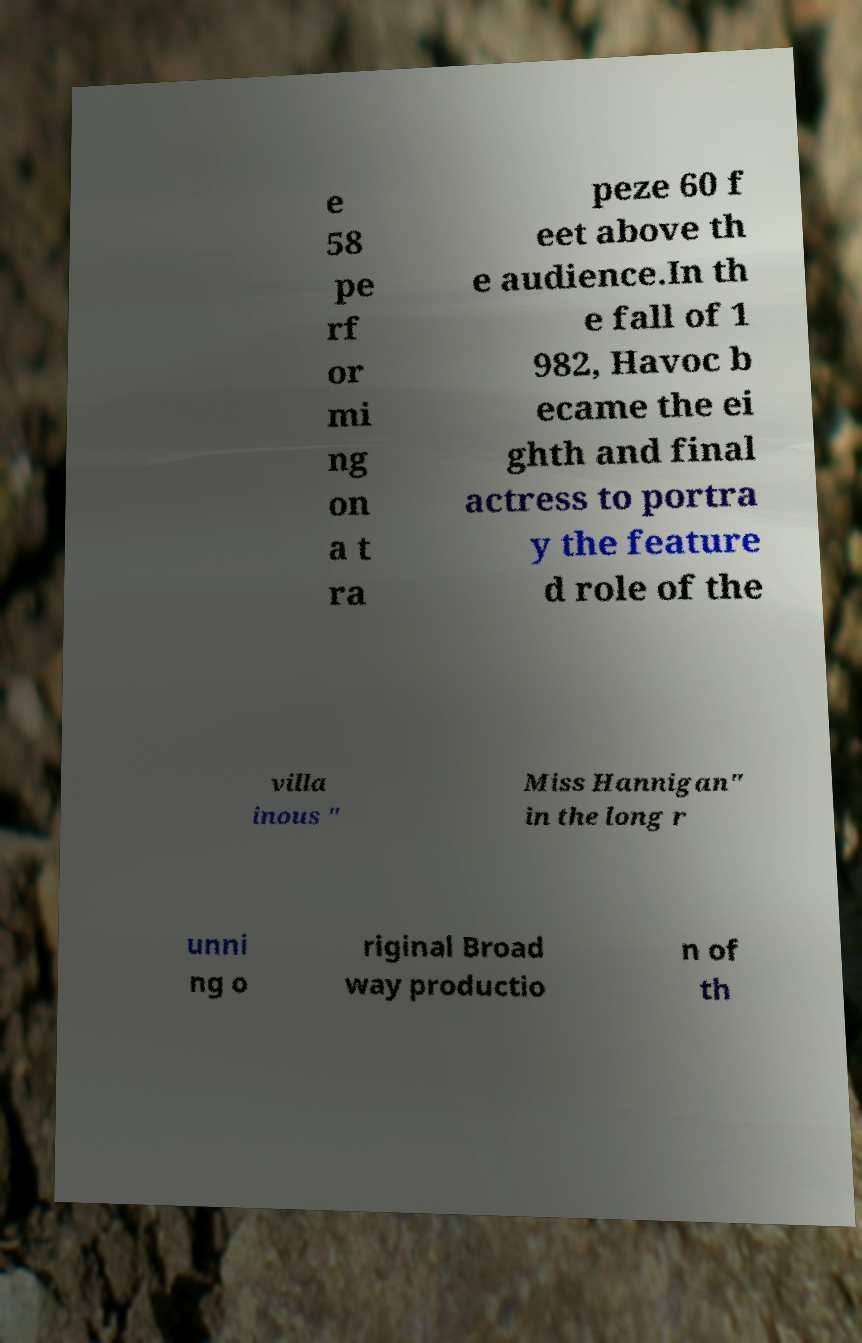Please identify and transcribe the text found in this image. e 58 pe rf or mi ng on a t ra peze 60 f eet above th e audience.In th e fall of 1 982, Havoc b ecame the ei ghth and final actress to portra y the feature d role of the villa inous " Miss Hannigan" in the long r unni ng o riginal Broad way productio n of th 